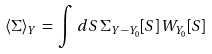<formula> <loc_0><loc_0><loc_500><loc_500>\langle \Sigma \rangle _ { Y } \, = \, \int \, d S \, \Sigma _ { Y - Y _ { 0 } } [ S ] \, W _ { Y _ { 0 } } [ S ]</formula> 